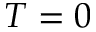<formula> <loc_0><loc_0><loc_500><loc_500>T = 0</formula> 